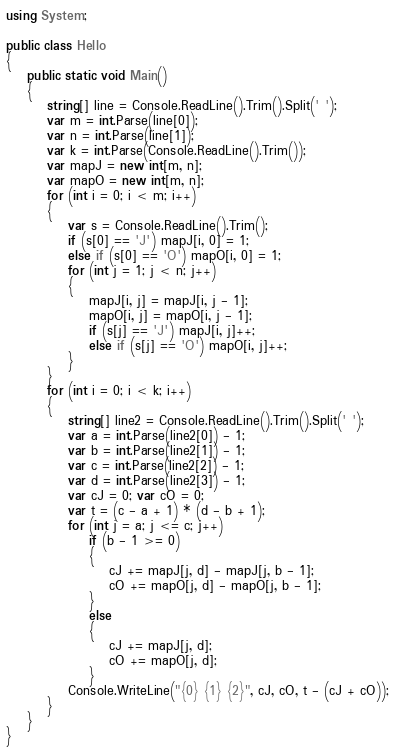<code> <loc_0><loc_0><loc_500><loc_500><_C#_>using System;

public class Hello
{
    public static void Main()
    {
        string[] line = Console.ReadLine().Trim().Split(' ');
        var m = int.Parse(line[0]);
        var n = int.Parse(line[1]);
        var k = int.Parse(Console.ReadLine().Trim());
        var mapJ = new int[m, n];
        var mapO = new int[m, n];
        for (int i = 0; i < m; i++)
        {
            var s = Console.ReadLine().Trim();
            if (s[0] == 'J') mapJ[i, 0] = 1;
            else if (s[0] == 'O') mapO[i, 0] = 1;
            for (int j = 1; j < n; j++)
            {
                mapJ[i, j] = mapJ[i, j - 1];
                mapO[i, j] = mapO[i, j - 1];
                if (s[j] == 'J') mapJ[i, j]++;
                else if (s[j] == 'O') mapO[i, j]++;
            }
        }
        for (int i = 0; i < k; i++)
        {
            string[] line2 = Console.ReadLine().Trim().Split(' ');
            var a = int.Parse(line2[0]) - 1;
            var b = int.Parse(line2[1]) - 1;
            var c = int.Parse(line2[2]) - 1;
            var d = int.Parse(line2[3]) - 1;
            var cJ = 0; var cO = 0;
            var t = (c - a + 1) * (d - b + 1);
            for (int j = a; j <= c; j++)
                if (b - 1 >= 0)
                {
                    cJ += mapJ[j, d] - mapJ[j, b - 1];
                    cO += mapO[j, d] - mapO[j, b - 1];
                }
                else
                {
                    cJ += mapJ[j, d];
                    cO += mapO[j, d];
                }
            Console.WriteLine("{0} {1} {2}", cJ, cO, t - (cJ + cO));
        }
    }
}
</code> 